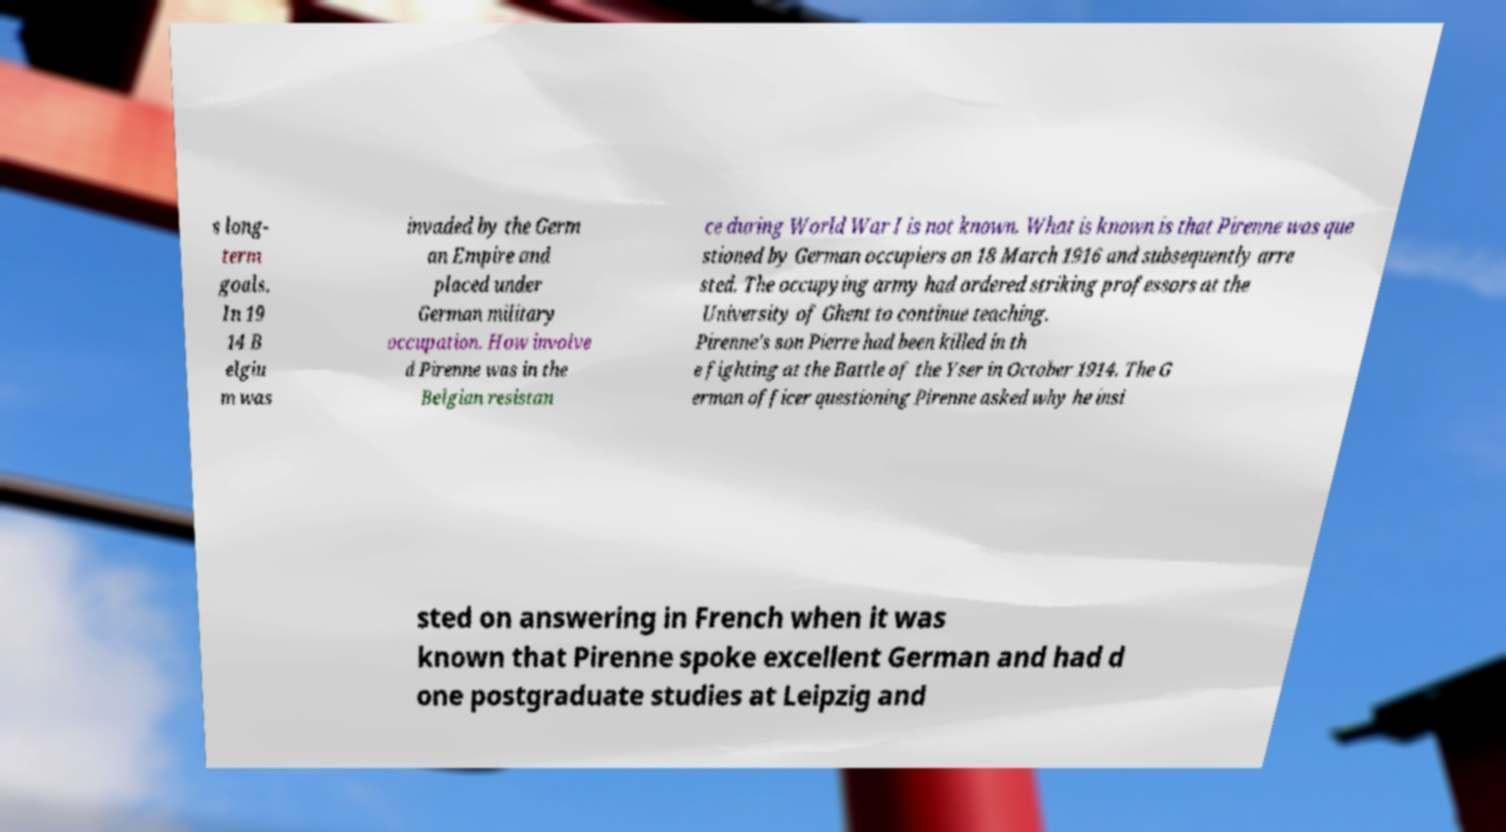For documentation purposes, I need the text within this image transcribed. Could you provide that? s long- term goals. In 19 14 B elgiu m was invaded by the Germ an Empire and placed under German military occupation. How involve d Pirenne was in the Belgian resistan ce during World War I is not known. What is known is that Pirenne was que stioned by German occupiers on 18 March 1916 and subsequently arre sted. The occupying army had ordered striking professors at the University of Ghent to continue teaching. Pirenne's son Pierre had been killed in th e fighting at the Battle of the Yser in October 1914. The G erman officer questioning Pirenne asked why he insi sted on answering in French when it was known that Pirenne spoke excellent German and had d one postgraduate studies at Leipzig and 